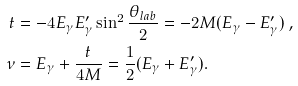<formula> <loc_0><loc_0><loc_500><loc_500>t & = - 4 E _ { \gamma } E _ { \gamma } ^ { \prime } \sin ^ { 2 } \frac { \theta _ { l a b } } { 2 } = - 2 M ( E _ { \gamma } - E _ { \gamma } ^ { \prime } ) \ , \\ \nu & = E _ { \gamma } + \frac { t } { 4 M } = \frac { 1 } { 2 } ( E _ { \gamma } + E _ { \gamma } ^ { \prime } ) .</formula> 